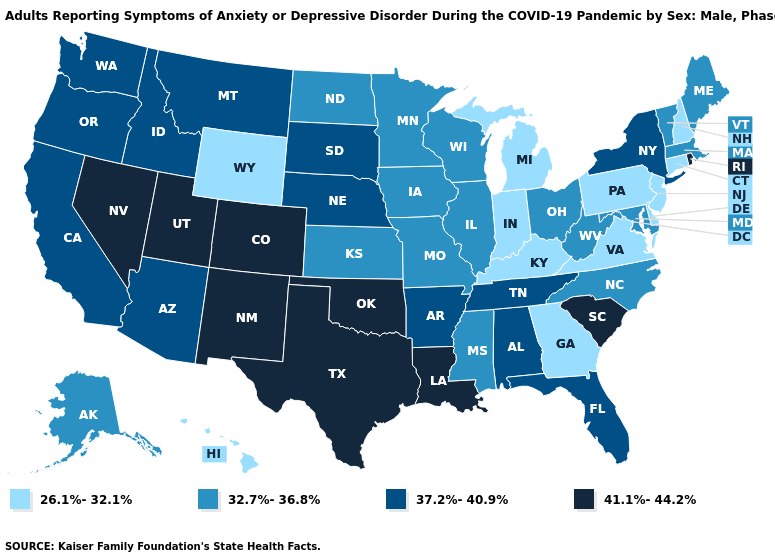What is the value of Arizona?
Concise answer only. 37.2%-40.9%. Does Oregon have the highest value in the West?
Short answer required. No. Among the states that border Maryland , does Virginia have the highest value?
Write a very short answer. No. Does Kansas have the same value as Colorado?
Be succinct. No. Name the states that have a value in the range 37.2%-40.9%?
Short answer required. Alabama, Arizona, Arkansas, California, Florida, Idaho, Montana, Nebraska, New York, Oregon, South Dakota, Tennessee, Washington. What is the lowest value in the South?
Concise answer only. 26.1%-32.1%. Name the states that have a value in the range 26.1%-32.1%?
Write a very short answer. Connecticut, Delaware, Georgia, Hawaii, Indiana, Kentucky, Michigan, New Hampshire, New Jersey, Pennsylvania, Virginia, Wyoming. What is the lowest value in the West?
Short answer required. 26.1%-32.1%. Which states hav the highest value in the West?
Answer briefly. Colorado, Nevada, New Mexico, Utah. What is the value of Texas?
Give a very brief answer. 41.1%-44.2%. Name the states that have a value in the range 26.1%-32.1%?
Quick response, please. Connecticut, Delaware, Georgia, Hawaii, Indiana, Kentucky, Michigan, New Hampshire, New Jersey, Pennsylvania, Virginia, Wyoming. What is the value of Tennessee?
Be succinct. 37.2%-40.9%. Name the states that have a value in the range 26.1%-32.1%?
Keep it brief. Connecticut, Delaware, Georgia, Hawaii, Indiana, Kentucky, Michigan, New Hampshire, New Jersey, Pennsylvania, Virginia, Wyoming. Does Illinois have a higher value than Oklahoma?
Keep it brief. No. Does the first symbol in the legend represent the smallest category?
Give a very brief answer. Yes. 